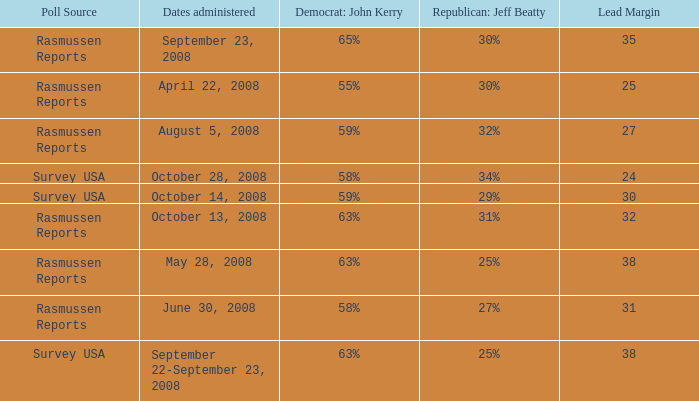What is the maximum lead margin on august 5, 2008? 27.0. 